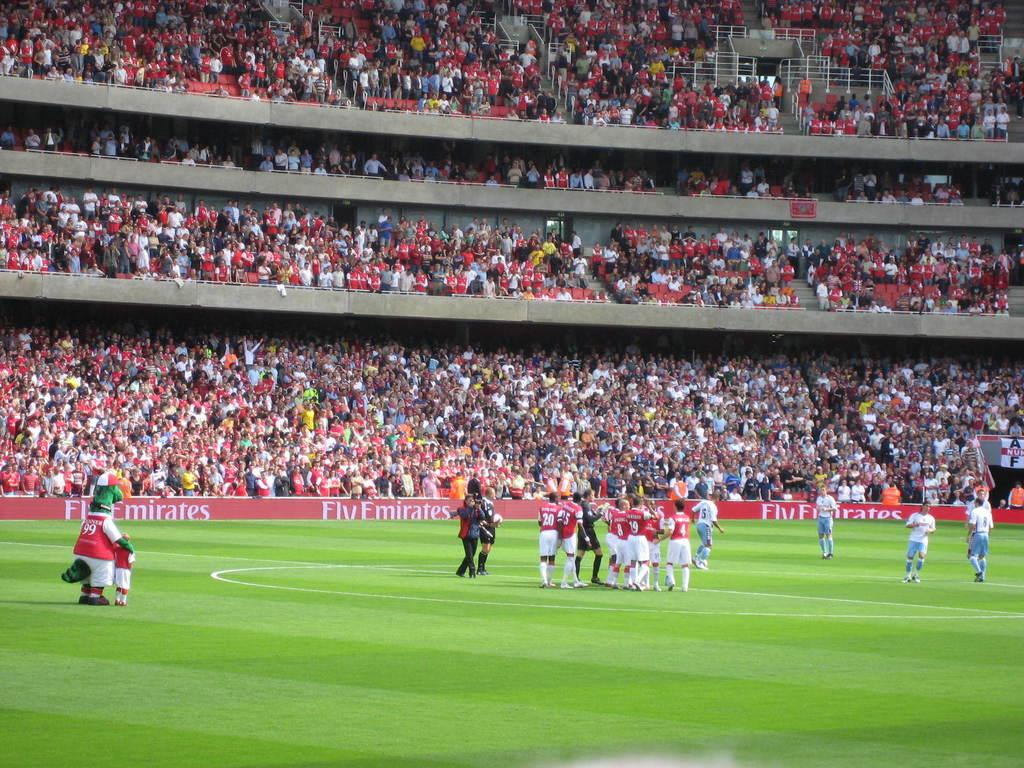Provide a one-sentence caption for the provided image. A stadium full of fans watch as the Fly Emirates take on a team in blue and white. 